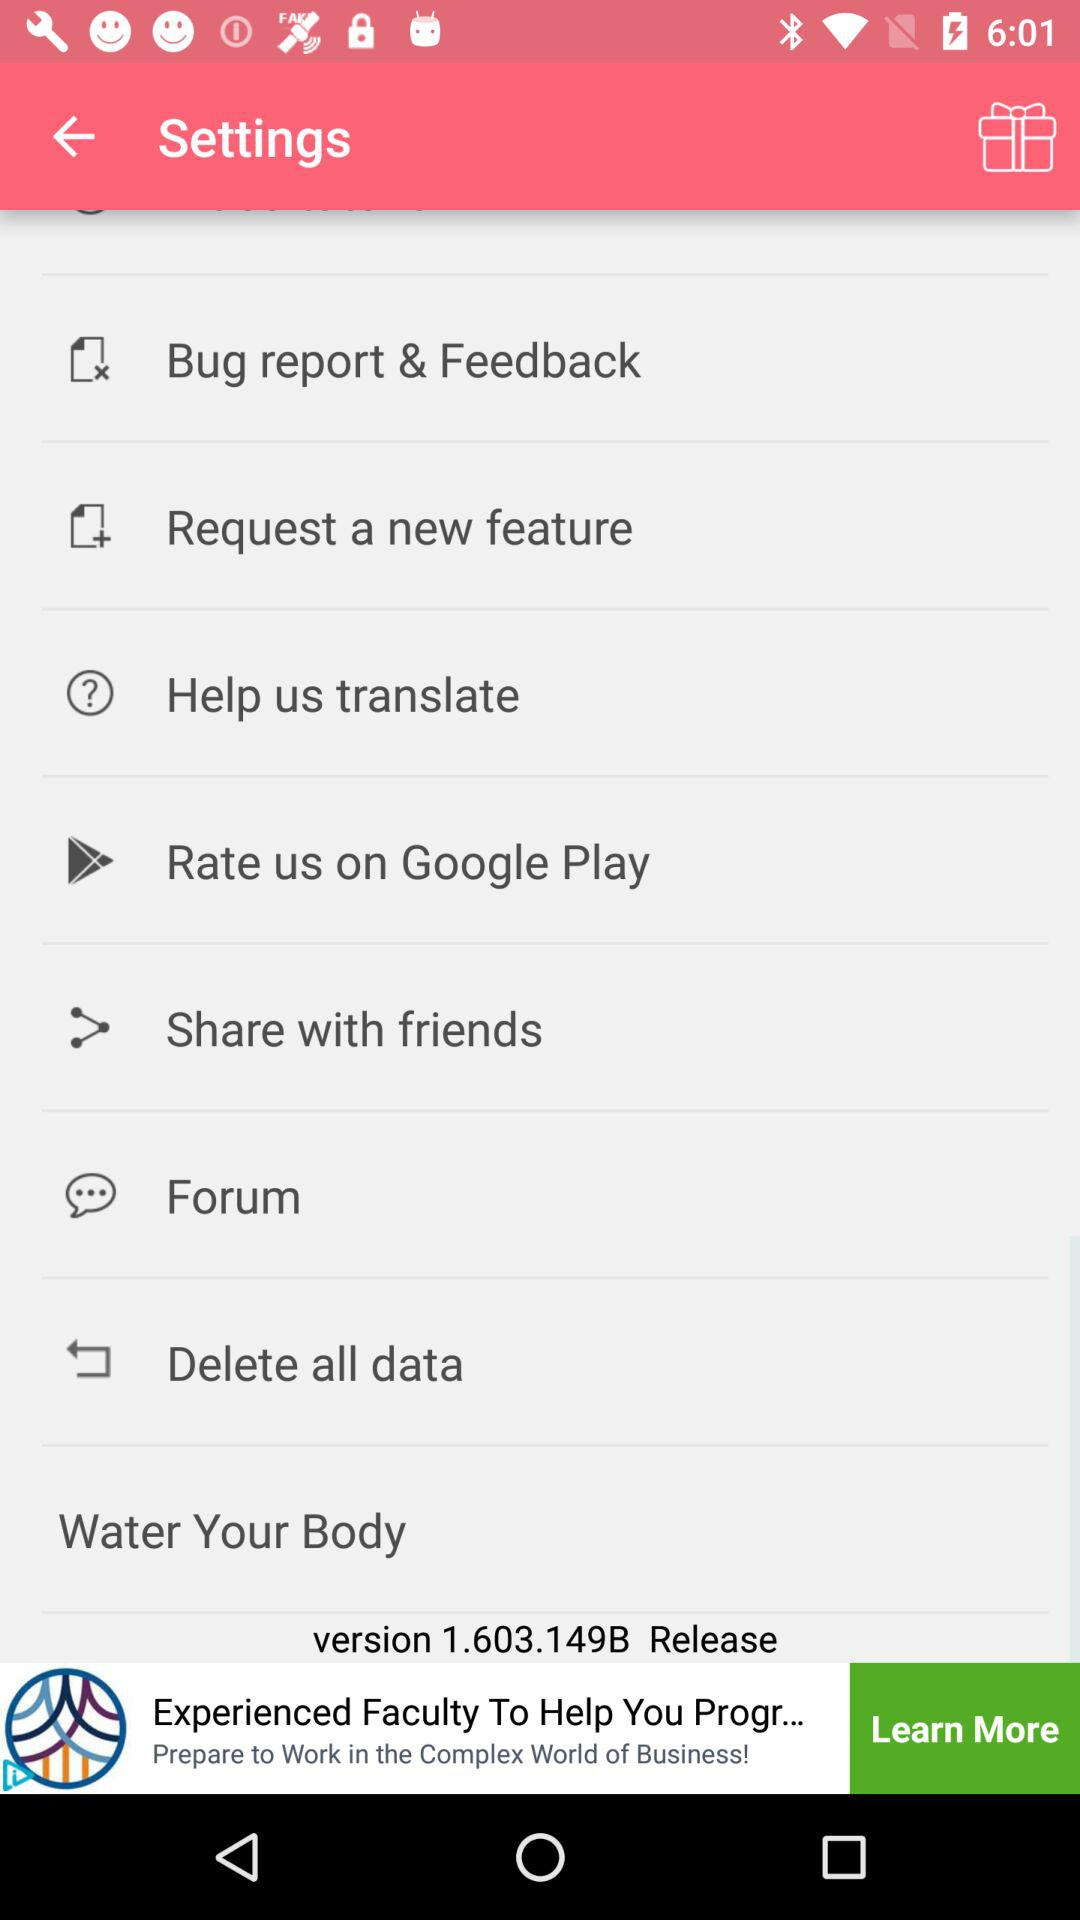What is the version? The version is 1.603.149B. 